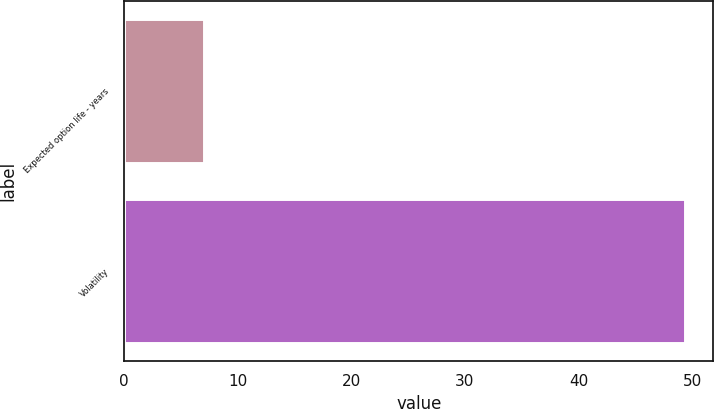<chart> <loc_0><loc_0><loc_500><loc_500><bar_chart><fcel>Expected option life - years<fcel>Volatility<nl><fcel>7<fcel>49.4<nl></chart> 